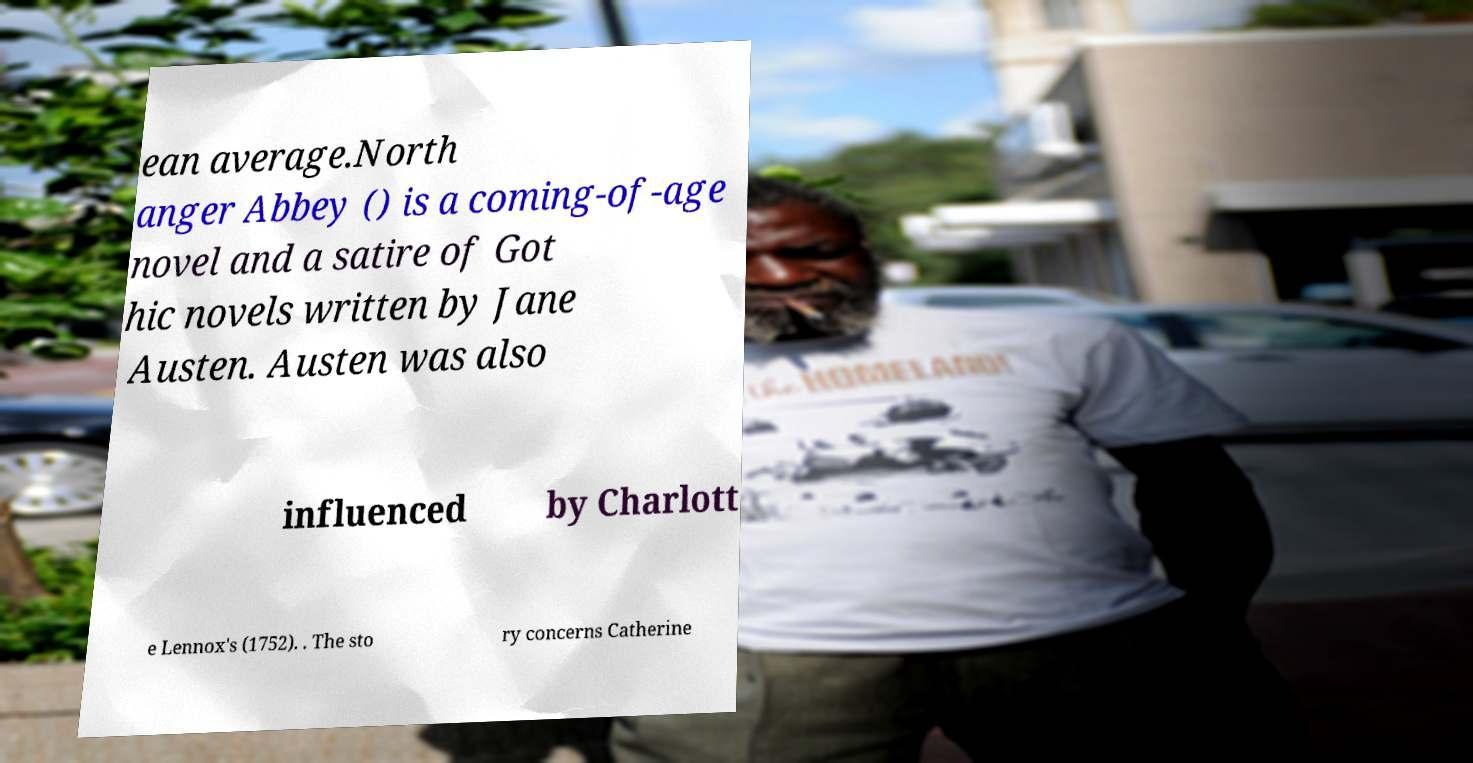I need the written content from this picture converted into text. Can you do that? ean average.North anger Abbey () is a coming-of-age novel and a satire of Got hic novels written by Jane Austen. Austen was also influenced by Charlott e Lennox's (1752). . The sto ry concerns Catherine 